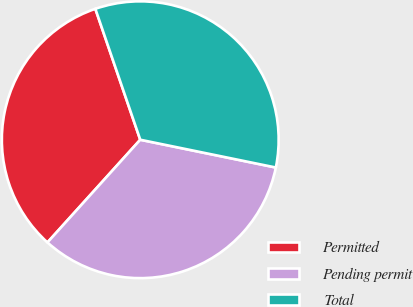Convert chart. <chart><loc_0><loc_0><loc_500><loc_500><pie_chart><fcel>Permitted<fcel>Pending permit<fcel>Total<nl><fcel>33.05%<fcel>33.48%<fcel>33.48%<nl></chart> 